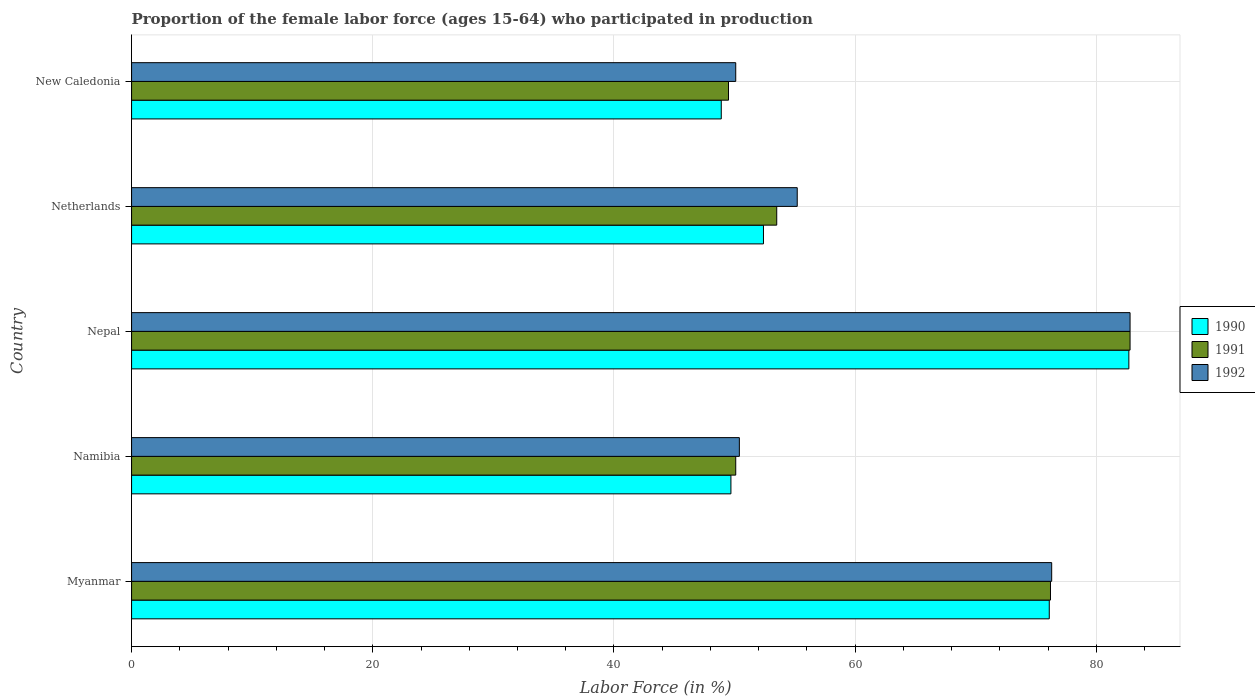How many different coloured bars are there?
Ensure brevity in your answer.  3. How many bars are there on the 1st tick from the top?
Ensure brevity in your answer.  3. What is the label of the 3rd group of bars from the top?
Make the answer very short. Nepal. In how many cases, is the number of bars for a given country not equal to the number of legend labels?
Your answer should be compact. 0. What is the proportion of the female labor force who participated in production in 1991 in Myanmar?
Keep it short and to the point. 76.2. Across all countries, what is the maximum proportion of the female labor force who participated in production in 1991?
Give a very brief answer. 82.8. Across all countries, what is the minimum proportion of the female labor force who participated in production in 1990?
Provide a succinct answer. 48.9. In which country was the proportion of the female labor force who participated in production in 1991 maximum?
Provide a short and direct response. Nepal. In which country was the proportion of the female labor force who participated in production in 1991 minimum?
Your answer should be very brief. New Caledonia. What is the total proportion of the female labor force who participated in production in 1991 in the graph?
Offer a terse response. 312.1. What is the difference between the proportion of the female labor force who participated in production in 1992 in Nepal and that in New Caledonia?
Your response must be concise. 32.7. What is the difference between the proportion of the female labor force who participated in production in 1990 in Netherlands and the proportion of the female labor force who participated in production in 1992 in Nepal?
Provide a succinct answer. -30.4. What is the average proportion of the female labor force who participated in production in 1991 per country?
Provide a succinct answer. 62.42. What is the difference between the proportion of the female labor force who participated in production in 1990 and proportion of the female labor force who participated in production in 1991 in Namibia?
Your answer should be compact. -0.4. In how many countries, is the proportion of the female labor force who participated in production in 1990 greater than 48 %?
Make the answer very short. 5. What is the ratio of the proportion of the female labor force who participated in production in 1991 in Myanmar to that in Netherlands?
Your answer should be compact. 1.42. Is the proportion of the female labor force who participated in production in 1991 in Nepal less than that in Netherlands?
Your answer should be compact. No. What is the difference between the highest and the second highest proportion of the female labor force who participated in production in 1991?
Your answer should be compact. 6.6. What is the difference between the highest and the lowest proportion of the female labor force who participated in production in 1991?
Your answer should be compact. 33.3. What does the 3rd bar from the top in Nepal represents?
Keep it short and to the point. 1990. What does the 2nd bar from the bottom in New Caledonia represents?
Offer a terse response. 1991. Is it the case that in every country, the sum of the proportion of the female labor force who participated in production in 1992 and proportion of the female labor force who participated in production in 1990 is greater than the proportion of the female labor force who participated in production in 1991?
Offer a terse response. Yes. How many countries are there in the graph?
Provide a succinct answer. 5. How many legend labels are there?
Your response must be concise. 3. How are the legend labels stacked?
Provide a short and direct response. Vertical. What is the title of the graph?
Make the answer very short. Proportion of the female labor force (ages 15-64) who participated in production. Does "1965" appear as one of the legend labels in the graph?
Provide a short and direct response. No. What is the label or title of the Y-axis?
Provide a succinct answer. Country. What is the Labor Force (in %) in 1990 in Myanmar?
Offer a terse response. 76.1. What is the Labor Force (in %) of 1991 in Myanmar?
Your answer should be very brief. 76.2. What is the Labor Force (in %) in 1992 in Myanmar?
Keep it short and to the point. 76.3. What is the Labor Force (in %) in 1990 in Namibia?
Offer a terse response. 49.7. What is the Labor Force (in %) in 1991 in Namibia?
Your answer should be compact. 50.1. What is the Labor Force (in %) in 1992 in Namibia?
Keep it short and to the point. 50.4. What is the Labor Force (in %) of 1990 in Nepal?
Your response must be concise. 82.7. What is the Labor Force (in %) in 1991 in Nepal?
Your answer should be compact. 82.8. What is the Labor Force (in %) of 1992 in Nepal?
Make the answer very short. 82.8. What is the Labor Force (in %) in 1990 in Netherlands?
Provide a short and direct response. 52.4. What is the Labor Force (in %) of 1991 in Netherlands?
Offer a very short reply. 53.5. What is the Labor Force (in %) in 1992 in Netherlands?
Ensure brevity in your answer.  55.2. What is the Labor Force (in %) of 1990 in New Caledonia?
Make the answer very short. 48.9. What is the Labor Force (in %) in 1991 in New Caledonia?
Your answer should be compact. 49.5. What is the Labor Force (in %) of 1992 in New Caledonia?
Offer a very short reply. 50.1. Across all countries, what is the maximum Labor Force (in %) of 1990?
Provide a short and direct response. 82.7. Across all countries, what is the maximum Labor Force (in %) in 1991?
Provide a succinct answer. 82.8. Across all countries, what is the maximum Labor Force (in %) in 1992?
Provide a short and direct response. 82.8. Across all countries, what is the minimum Labor Force (in %) in 1990?
Keep it short and to the point. 48.9. Across all countries, what is the minimum Labor Force (in %) of 1991?
Provide a short and direct response. 49.5. Across all countries, what is the minimum Labor Force (in %) in 1992?
Provide a short and direct response. 50.1. What is the total Labor Force (in %) of 1990 in the graph?
Your response must be concise. 309.8. What is the total Labor Force (in %) in 1991 in the graph?
Make the answer very short. 312.1. What is the total Labor Force (in %) of 1992 in the graph?
Offer a terse response. 314.8. What is the difference between the Labor Force (in %) of 1990 in Myanmar and that in Namibia?
Keep it short and to the point. 26.4. What is the difference between the Labor Force (in %) of 1991 in Myanmar and that in Namibia?
Give a very brief answer. 26.1. What is the difference between the Labor Force (in %) of 1992 in Myanmar and that in Namibia?
Your response must be concise. 25.9. What is the difference between the Labor Force (in %) of 1991 in Myanmar and that in Nepal?
Offer a very short reply. -6.6. What is the difference between the Labor Force (in %) of 1990 in Myanmar and that in Netherlands?
Keep it short and to the point. 23.7. What is the difference between the Labor Force (in %) of 1991 in Myanmar and that in Netherlands?
Offer a terse response. 22.7. What is the difference between the Labor Force (in %) in 1992 in Myanmar and that in Netherlands?
Your response must be concise. 21.1. What is the difference between the Labor Force (in %) of 1990 in Myanmar and that in New Caledonia?
Provide a short and direct response. 27.2. What is the difference between the Labor Force (in %) of 1991 in Myanmar and that in New Caledonia?
Ensure brevity in your answer.  26.7. What is the difference between the Labor Force (in %) of 1992 in Myanmar and that in New Caledonia?
Make the answer very short. 26.2. What is the difference between the Labor Force (in %) in 1990 in Namibia and that in Nepal?
Give a very brief answer. -33. What is the difference between the Labor Force (in %) of 1991 in Namibia and that in Nepal?
Offer a terse response. -32.7. What is the difference between the Labor Force (in %) of 1992 in Namibia and that in Nepal?
Ensure brevity in your answer.  -32.4. What is the difference between the Labor Force (in %) in 1990 in Namibia and that in Netherlands?
Offer a very short reply. -2.7. What is the difference between the Labor Force (in %) of 1992 in Namibia and that in Netherlands?
Give a very brief answer. -4.8. What is the difference between the Labor Force (in %) of 1990 in Namibia and that in New Caledonia?
Your response must be concise. 0.8. What is the difference between the Labor Force (in %) of 1992 in Namibia and that in New Caledonia?
Your answer should be compact. 0.3. What is the difference between the Labor Force (in %) of 1990 in Nepal and that in Netherlands?
Your answer should be very brief. 30.3. What is the difference between the Labor Force (in %) of 1991 in Nepal and that in Netherlands?
Your answer should be compact. 29.3. What is the difference between the Labor Force (in %) of 1992 in Nepal and that in Netherlands?
Your answer should be compact. 27.6. What is the difference between the Labor Force (in %) in 1990 in Nepal and that in New Caledonia?
Provide a succinct answer. 33.8. What is the difference between the Labor Force (in %) in 1991 in Nepal and that in New Caledonia?
Provide a short and direct response. 33.3. What is the difference between the Labor Force (in %) in 1992 in Nepal and that in New Caledonia?
Offer a terse response. 32.7. What is the difference between the Labor Force (in %) of 1990 in Netherlands and that in New Caledonia?
Make the answer very short. 3.5. What is the difference between the Labor Force (in %) of 1991 in Netherlands and that in New Caledonia?
Ensure brevity in your answer.  4. What is the difference between the Labor Force (in %) in 1990 in Myanmar and the Labor Force (in %) in 1991 in Namibia?
Keep it short and to the point. 26. What is the difference between the Labor Force (in %) of 1990 in Myanmar and the Labor Force (in %) of 1992 in Namibia?
Offer a terse response. 25.7. What is the difference between the Labor Force (in %) in 1991 in Myanmar and the Labor Force (in %) in 1992 in Namibia?
Ensure brevity in your answer.  25.8. What is the difference between the Labor Force (in %) in 1991 in Myanmar and the Labor Force (in %) in 1992 in Nepal?
Your response must be concise. -6.6. What is the difference between the Labor Force (in %) in 1990 in Myanmar and the Labor Force (in %) in 1991 in Netherlands?
Keep it short and to the point. 22.6. What is the difference between the Labor Force (in %) in 1990 in Myanmar and the Labor Force (in %) in 1992 in Netherlands?
Offer a very short reply. 20.9. What is the difference between the Labor Force (in %) in 1990 in Myanmar and the Labor Force (in %) in 1991 in New Caledonia?
Provide a short and direct response. 26.6. What is the difference between the Labor Force (in %) of 1990 in Myanmar and the Labor Force (in %) of 1992 in New Caledonia?
Your answer should be compact. 26. What is the difference between the Labor Force (in %) of 1991 in Myanmar and the Labor Force (in %) of 1992 in New Caledonia?
Keep it short and to the point. 26.1. What is the difference between the Labor Force (in %) of 1990 in Namibia and the Labor Force (in %) of 1991 in Nepal?
Your response must be concise. -33.1. What is the difference between the Labor Force (in %) of 1990 in Namibia and the Labor Force (in %) of 1992 in Nepal?
Offer a terse response. -33.1. What is the difference between the Labor Force (in %) of 1991 in Namibia and the Labor Force (in %) of 1992 in Nepal?
Ensure brevity in your answer.  -32.7. What is the difference between the Labor Force (in %) in 1990 in Namibia and the Labor Force (in %) in 1992 in Netherlands?
Keep it short and to the point. -5.5. What is the difference between the Labor Force (in %) in 1990 in Namibia and the Labor Force (in %) in 1991 in New Caledonia?
Give a very brief answer. 0.2. What is the difference between the Labor Force (in %) of 1990 in Nepal and the Labor Force (in %) of 1991 in Netherlands?
Make the answer very short. 29.2. What is the difference between the Labor Force (in %) in 1991 in Nepal and the Labor Force (in %) in 1992 in Netherlands?
Provide a succinct answer. 27.6. What is the difference between the Labor Force (in %) in 1990 in Nepal and the Labor Force (in %) in 1991 in New Caledonia?
Your answer should be very brief. 33.2. What is the difference between the Labor Force (in %) in 1990 in Nepal and the Labor Force (in %) in 1992 in New Caledonia?
Provide a short and direct response. 32.6. What is the difference between the Labor Force (in %) of 1991 in Nepal and the Labor Force (in %) of 1992 in New Caledonia?
Give a very brief answer. 32.7. What is the difference between the Labor Force (in %) in 1990 in Netherlands and the Labor Force (in %) in 1991 in New Caledonia?
Make the answer very short. 2.9. What is the difference between the Labor Force (in %) of 1990 in Netherlands and the Labor Force (in %) of 1992 in New Caledonia?
Ensure brevity in your answer.  2.3. What is the average Labor Force (in %) of 1990 per country?
Ensure brevity in your answer.  61.96. What is the average Labor Force (in %) in 1991 per country?
Give a very brief answer. 62.42. What is the average Labor Force (in %) of 1992 per country?
Give a very brief answer. 62.96. What is the difference between the Labor Force (in %) in 1990 and Labor Force (in %) in 1992 in Myanmar?
Provide a short and direct response. -0.2. What is the difference between the Labor Force (in %) of 1990 and Labor Force (in %) of 1991 in Namibia?
Offer a terse response. -0.4. What is the difference between the Labor Force (in %) of 1990 and Labor Force (in %) of 1992 in Namibia?
Your answer should be very brief. -0.7. What is the difference between the Labor Force (in %) of 1991 and Labor Force (in %) of 1992 in Namibia?
Ensure brevity in your answer.  -0.3. What is the difference between the Labor Force (in %) of 1990 and Labor Force (in %) of 1991 in Netherlands?
Your answer should be compact. -1.1. What is the difference between the Labor Force (in %) of 1990 and Labor Force (in %) of 1992 in Netherlands?
Give a very brief answer. -2.8. What is the difference between the Labor Force (in %) of 1991 and Labor Force (in %) of 1992 in New Caledonia?
Offer a terse response. -0.6. What is the ratio of the Labor Force (in %) of 1990 in Myanmar to that in Namibia?
Offer a very short reply. 1.53. What is the ratio of the Labor Force (in %) of 1991 in Myanmar to that in Namibia?
Provide a short and direct response. 1.52. What is the ratio of the Labor Force (in %) in 1992 in Myanmar to that in Namibia?
Provide a succinct answer. 1.51. What is the ratio of the Labor Force (in %) in 1990 in Myanmar to that in Nepal?
Make the answer very short. 0.92. What is the ratio of the Labor Force (in %) of 1991 in Myanmar to that in Nepal?
Offer a terse response. 0.92. What is the ratio of the Labor Force (in %) in 1992 in Myanmar to that in Nepal?
Offer a terse response. 0.92. What is the ratio of the Labor Force (in %) of 1990 in Myanmar to that in Netherlands?
Provide a short and direct response. 1.45. What is the ratio of the Labor Force (in %) in 1991 in Myanmar to that in Netherlands?
Provide a short and direct response. 1.42. What is the ratio of the Labor Force (in %) in 1992 in Myanmar to that in Netherlands?
Your answer should be very brief. 1.38. What is the ratio of the Labor Force (in %) in 1990 in Myanmar to that in New Caledonia?
Keep it short and to the point. 1.56. What is the ratio of the Labor Force (in %) in 1991 in Myanmar to that in New Caledonia?
Your response must be concise. 1.54. What is the ratio of the Labor Force (in %) in 1992 in Myanmar to that in New Caledonia?
Provide a short and direct response. 1.52. What is the ratio of the Labor Force (in %) in 1990 in Namibia to that in Nepal?
Give a very brief answer. 0.6. What is the ratio of the Labor Force (in %) of 1991 in Namibia to that in Nepal?
Keep it short and to the point. 0.61. What is the ratio of the Labor Force (in %) of 1992 in Namibia to that in Nepal?
Your response must be concise. 0.61. What is the ratio of the Labor Force (in %) of 1990 in Namibia to that in Netherlands?
Keep it short and to the point. 0.95. What is the ratio of the Labor Force (in %) in 1991 in Namibia to that in Netherlands?
Your response must be concise. 0.94. What is the ratio of the Labor Force (in %) of 1992 in Namibia to that in Netherlands?
Your response must be concise. 0.91. What is the ratio of the Labor Force (in %) of 1990 in Namibia to that in New Caledonia?
Your answer should be compact. 1.02. What is the ratio of the Labor Force (in %) in 1991 in Namibia to that in New Caledonia?
Provide a succinct answer. 1.01. What is the ratio of the Labor Force (in %) in 1990 in Nepal to that in Netherlands?
Keep it short and to the point. 1.58. What is the ratio of the Labor Force (in %) of 1991 in Nepal to that in Netherlands?
Your answer should be very brief. 1.55. What is the ratio of the Labor Force (in %) of 1990 in Nepal to that in New Caledonia?
Offer a terse response. 1.69. What is the ratio of the Labor Force (in %) in 1991 in Nepal to that in New Caledonia?
Give a very brief answer. 1.67. What is the ratio of the Labor Force (in %) in 1992 in Nepal to that in New Caledonia?
Give a very brief answer. 1.65. What is the ratio of the Labor Force (in %) in 1990 in Netherlands to that in New Caledonia?
Give a very brief answer. 1.07. What is the ratio of the Labor Force (in %) in 1991 in Netherlands to that in New Caledonia?
Offer a very short reply. 1.08. What is the ratio of the Labor Force (in %) of 1992 in Netherlands to that in New Caledonia?
Give a very brief answer. 1.1. What is the difference between the highest and the second highest Labor Force (in %) in 1990?
Keep it short and to the point. 6.6. What is the difference between the highest and the second highest Labor Force (in %) in 1992?
Make the answer very short. 6.5. What is the difference between the highest and the lowest Labor Force (in %) in 1990?
Your response must be concise. 33.8. What is the difference between the highest and the lowest Labor Force (in %) in 1991?
Your answer should be compact. 33.3. What is the difference between the highest and the lowest Labor Force (in %) of 1992?
Your answer should be very brief. 32.7. 